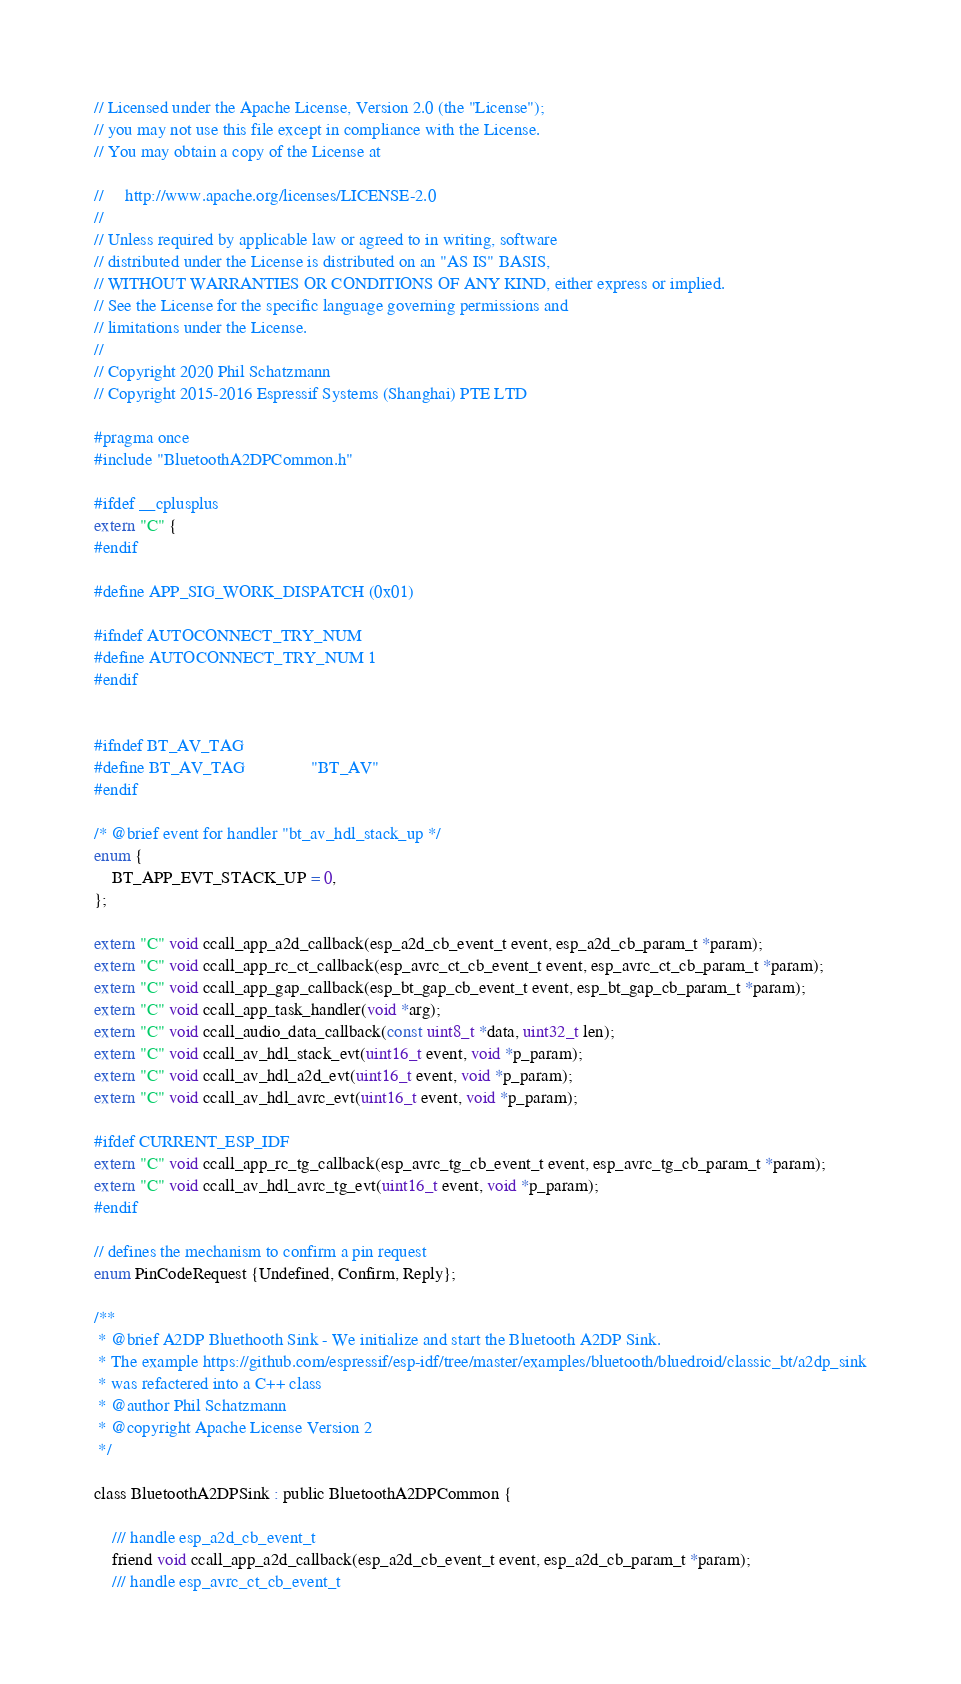<code> <loc_0><loc_0><loc_500><loc_500><_C_>// Licensed under the Apache License, Version 2.0 (the "License");
// you may not use this file except in compliance with the License.
// You may obtain a copy of the License at

//     http://www.apache.org/licenses/LICENSE-2.0
//
// Unless required by applicable law or agreed to in writing, software
// distributed under the License is distributed on an "AS IS" BASIS,
// WITHOUT WARRANTIES OR CONDITIONS OF ANY KIND, either express or implied.
// See the License for the specific language governing permissions and
// limitations under the License.
//
// Copyright 2020 Phil Schatzmann
// Copyright 2015-2016 Espressif Systems (Shanghai) PTE LTD

#pragma once
#include "BluetoothA2DPCommon.h"

#ifdef __cplusplus
extern "C" {
#endif

#define APP_SIG_WORK_DISPATCH (0x01)

#ifndef AUTOCONNECT_TRY_NUM
#define AUTOCONNECT_TRY_NUM 1
#endif


#ifndef BT_AV_TAG
#define BT_AV_TAG               "BT_AV"
#endif

/* @brief event for handler "bt_av_hdl_stack_up */
enum {
    BT_APP_EVT_STACK_UP = 0,
};

extern "C" void ccall_app_a2d_callback(esp_a2d_cb_event_t event, esp_a2d_cb_param_t *param);
extern "C" void ccall_app_rc_ct_callback(esp_avrc_ct_cb_event_t event, esp_avrc_ct_cb_param_t *param);
extern "C" void ccall_app_gap_callback(esp_bt_gap_cb_event_t event, esp_bt_gap_cb_param_t *param);
extern "C" void ccall_app_task_handler(void *arg);
extern "C" void ccall_audio_data_callback(const uint8_t *data, uint32_t len);
extern "C" void ccall_av_hdl_stack_evt(uint16_t event, void *p_param);
extern "C" void ccall_av_hdl_a2d_evt(uint16_t event, void *p_param);
extern "C" void ccall_av_hdl_avrc_evt(uint16_t event, void *p_param);

#ifdef CURRENT_ESP_IDF
extern "C" void ccall_app_rc_tg_callback(esp_avrc_tg_cb_event_t event, esp_avrc_tg_cb_param_t *param);
extern "C" void ccall_av_hdl_avrc_tg_evt(uint16_t event, void *p_param);
#endif    

// defines the mechanism to confirm a pin request
enum PinCodeRequest {Undefined, Confirm, Reply};

/**
 * @brief A2DP Bluethooth Sink - We initialize and start the Bluetooth A2DP Sink. 
 * The example https://github.com/espressif/esp-idf/tree/master/examples/bluetooth/bluedroid/classic_bt/a2dp_sink
 * was refactered into a C++ class 
 * @author Phil Schatzmann
 * @copyright Apache License Version 2
 */

class BluetoothA2DPSink : public BluetoothA2DPCommon {

    /// handle esp_a2d_cb_event_t 
    friend void ccall_app_a2d_callback(esp_a2d_cb_event_t event, esp_a2d_cb_param_t *param);
    /// handle esp_avrc_ct_cb_event_t</code> 